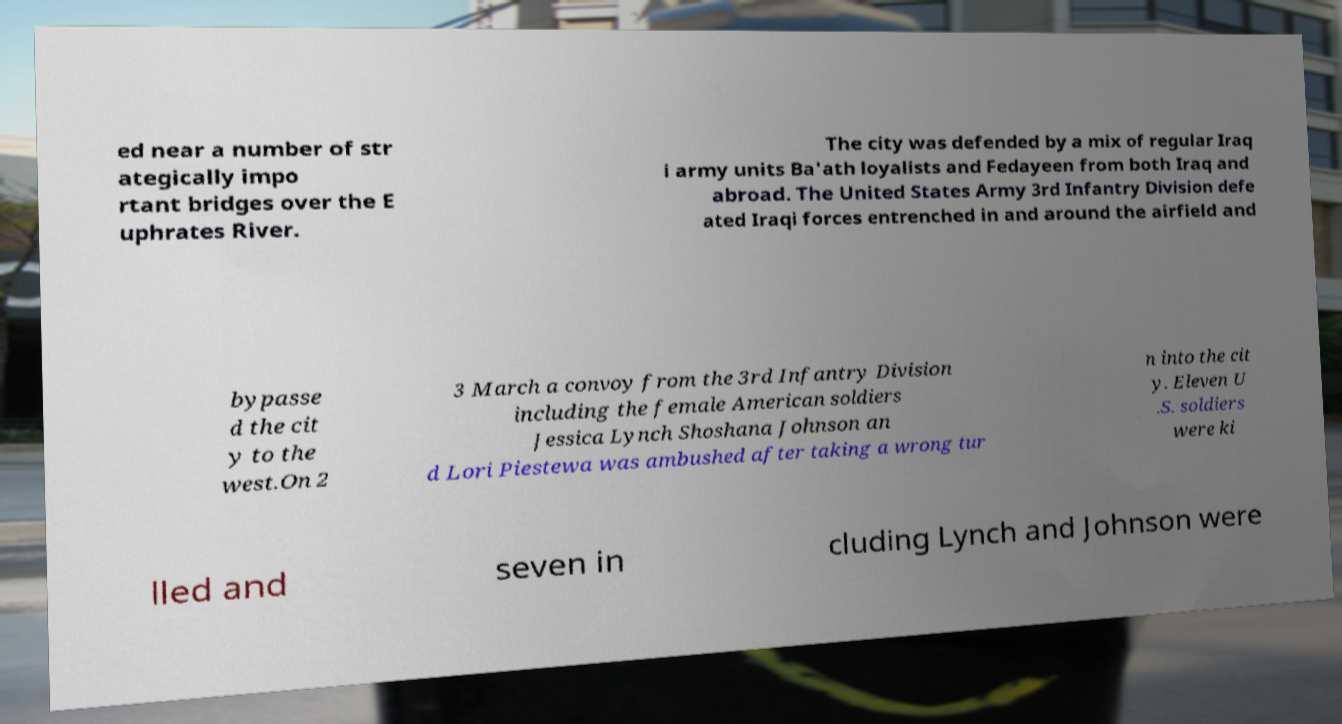Can you accurately transcribe the text from the provided image for me? ed near a number of str ategically impo rtant bridges over the E uphrates River. The city was defended by a mix of regular Iraq i army units Ba'ath loyalists and Fedayeen from both Iraq and abroad. The United States Army 3rd Infantry Division defe ated Iraqi forces entrenched in and around the airfield and bypasse d the cit y to the west.On 2 3 March a convoy from the 3rd Infantry Division including the female American soldiers Jessica Lynch Shoshana Johnson an d Lori Piestewa was ambushed after taking a wrong tur n into the cit y. Eleven U .S. soldiers were ki lled and seven in cluding Lynch and Johnson were 